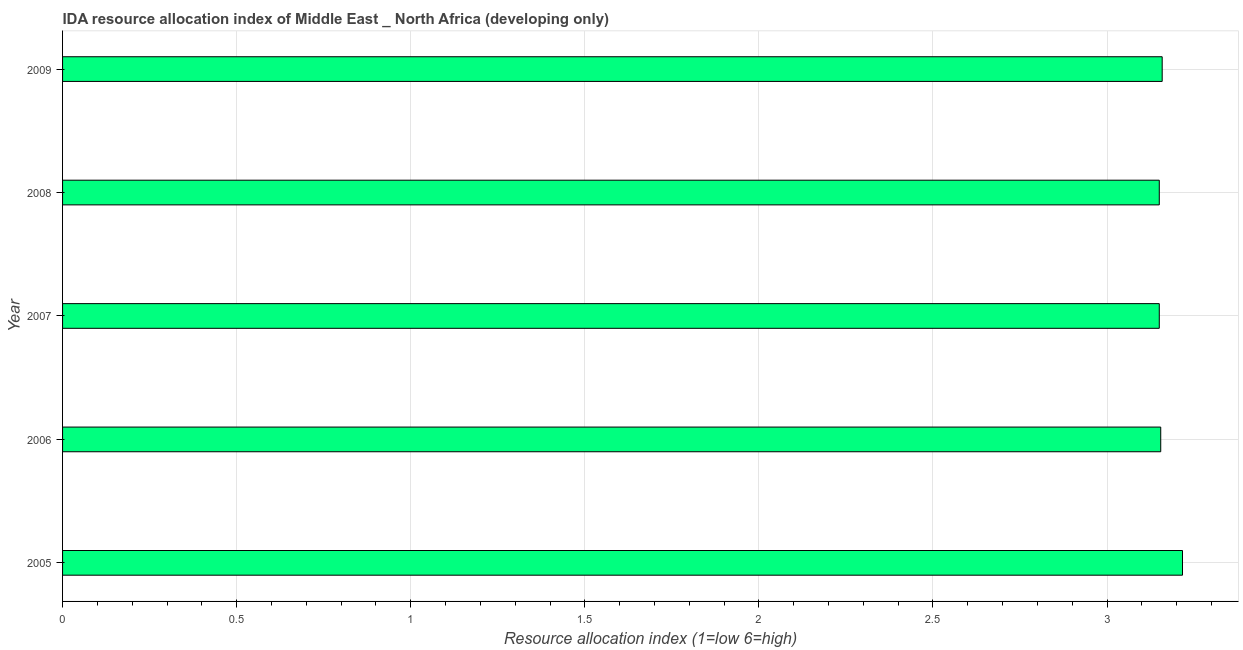Does the graph contain any zero values?
Your answer should be compact. No. Does the graph contain grids?
Your response must be concise. Yes. What is the title of the graph?
Provide a succinct answer. IDA resource allocation index of Middle East _ North Africa (developing only). What is the label or title of the X-axis?
Keep it short and to the point. Resource allocation index (1=low 6=high). What is the label or title of the Y-axis?
Provide a short and direct response. Year. What is the ida resource allocation index in 2008?
Keep it short and to the point. 3.15. Across all years, what is the maximum ida resource allocation index?
Keep it short and to the point. 3.22. Across all years, what is the minimum ida resource allocation index?
Your answer should be very brief. 3.15. In which year was the ida resource allocation index maximum?
Keep it short and to the point. 2005. In which year was the ida resource allocation index minimum?
Your answer should be compact. 2007. What is the sum of the ida resource allocation index?
Offer a very short reply. 15.83. What is the difference between the ida resource allocation index in 2005 and 2008?
Ensure brevity in your answer.  0.07. What is the average ida resource allocation index per year?
Give a very brief answer. 3.17. What is the median ida resource allocation index?
Give a very brief answer. 3.15. Is the ida resource allocation index in 2005 less than that in 2008?
Make the answer very short. No. What is the difference between the highest and the second highest ida resource allocation index?
Ensure brevity in your answer.  0.06. What is the difference between the highest and the lowest ida resource allocation index?
Your answer should be very brief. 0.07. Are all the bars in the graph horizontal?
Offer a very short reply. Yes. How many years are there in the graph?
Give a very brief answer. 5. What is the difference between two consecutive major ticks on the X-axis?
Offer a very short reply. 0.5. What is the Resource allocation index (1=low 6=high) in 2005?
Offer a very short reply. 3.22. What is the Resource allocation index (1=low 6=high) of 2006?
Make the answer very short. 3.15. What is the Resource allocation index (1=low 6=high) of 2007?
Your response must be concise. 3.15. What is the Resource allocation index (1=low 6=high) in 2008?
Offer a terse response. 3.15. What is the Resource allocation index (1=low 6=high) in 2009?
Your answer should be compact. 3.16. What is the difference between the Resource allocation index (1=low 6=high) in 2005 and 2006?
Offer a terse response. 0.06. What is the difference between the Resource allocation index (1=low 6=high) in 2005 and 2007?
Ensure brevity in your answer.  0.07. What is the difference between the Resource allocation index (1=low 6=high) in 2005 and 2008?
Your answer should be compact. 0.07. What is the difference between the Resource allocation index (1=low 6=high) in 2005 and 2009?
Ensure brevity in your answer.  0.06. What is the difference between the Resource allocation index (1=low 6=high) in 2006 and 2007?
Give a very brief answer. 0. What is the difference between the Resource allocation index (1=low 6=high) in 2006 and 2008?
Your answer should be compact. 0. What is the difference between the Resource allocation index (1=low 6=high) in 2006 and 2009?
Keep it short and to the point. -0. What is the difference between the Resource allocation index (1=low 6=high) in 2007 and 2009?
Make the answer very short. -0.01. What is the difference between the Resource allocation index (1=low 6=high) in 2008 and 2009?
Offer a very short reply. -0.01. What is the ratio of the Resource allocation index (1=low 6=high) in 2005 to that in 2006?
Offer a terse response. 1.02. What is the ratio of the Resource allocation index (1=low 6=high) in 2005 to that in 2008?
Your response must be concise. 1.02. What is the ratio of the Resource allocation index (1=low 6=high) in 2005 to that in 2009?
Ensure brevity in your answer.  1.02. What is the ratio of the Resource allocation index (1=low 6=high) in 2006 to that in 2008?
Your answer should be compact. 1. What is the ratio of the Resource allocation index (1=low 6=high) in 2007 to that in 2008?
Your answer should be very brief. 1. 